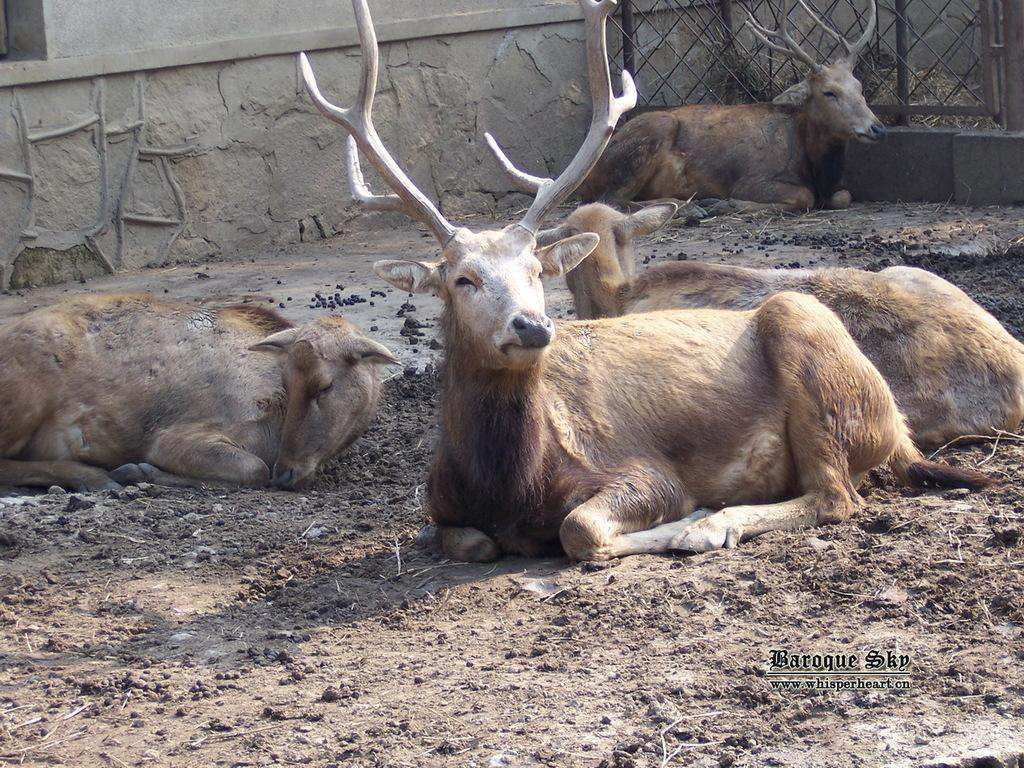What animals can be seen in the image? There are deer in the image. What are the deer doing in the image? The deer are sitting on the ground. What can be seen in the background of the image? There is a wall and fencing in the background of the image. Is there any text or logo visible in the image? Yes, there is a watermark in the bottom right corner of the image. Can you see any bun in the image? There is no bun present in the image. Are the deer in a zoo in the image? The image does not provide any information about the location of the deer or whether they are in a zoo. 